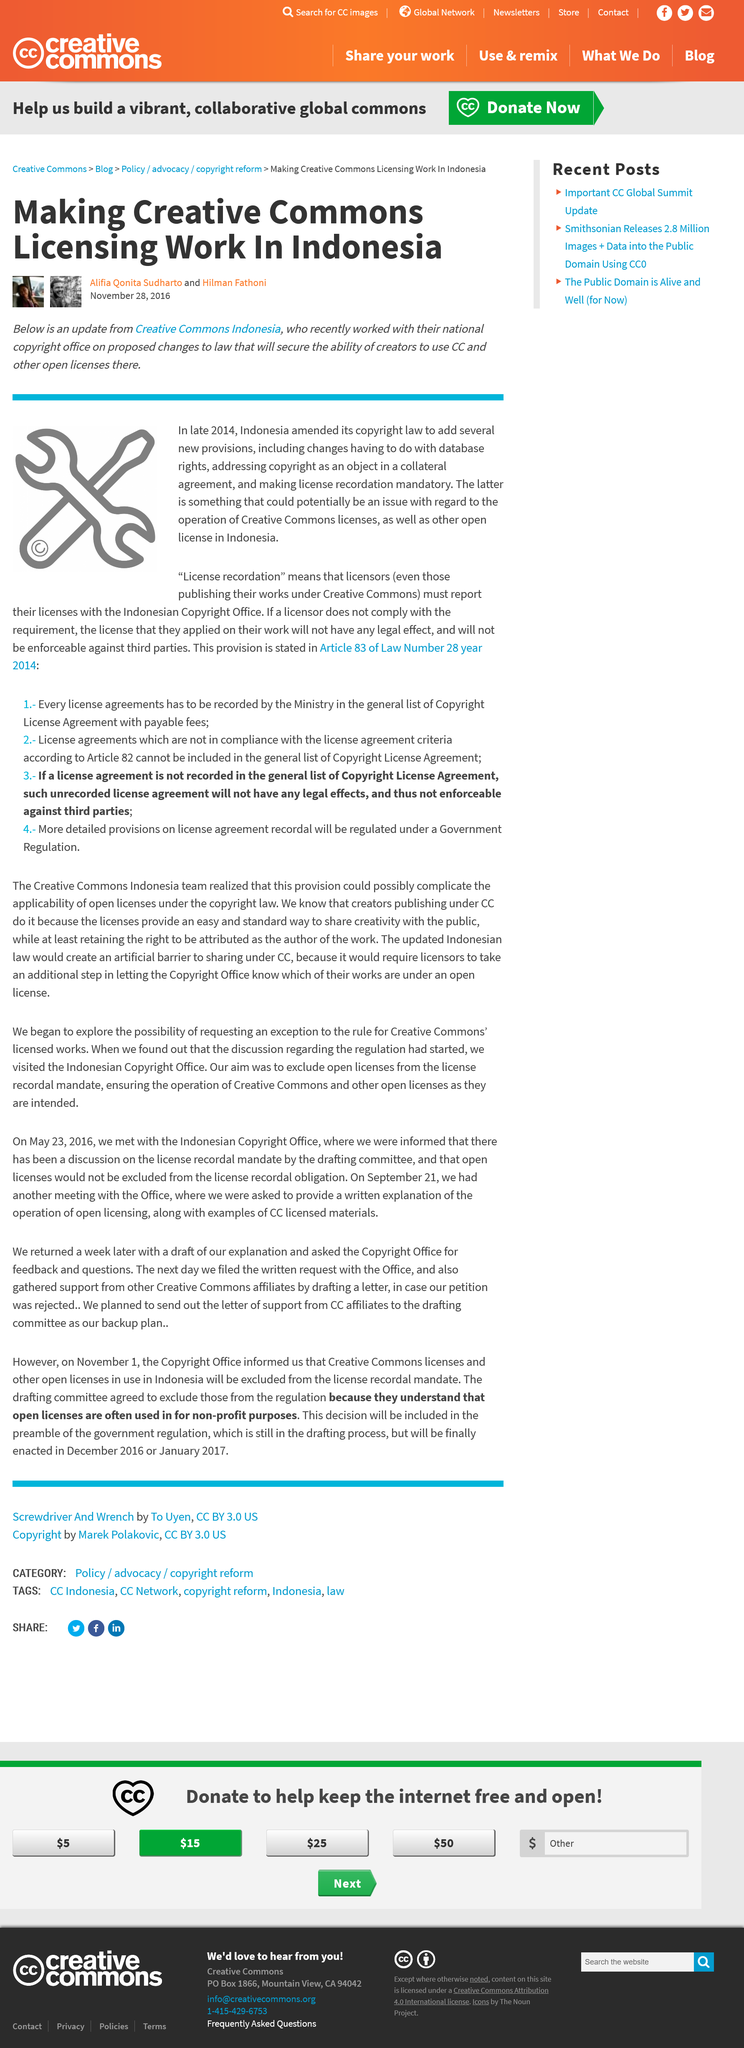Specify some key components in this picture. The woman depicted in the image is Alifia Qonita Sudharto. The person in the image is Hilman Fathoni. In Indonesia, "licence recordation" is the process by which licensors must report their licences with the Indonesian Copyright Office. This is to ensure that all licences granted in the country are properly recorded and acknowledged by the appropriate authorities. 